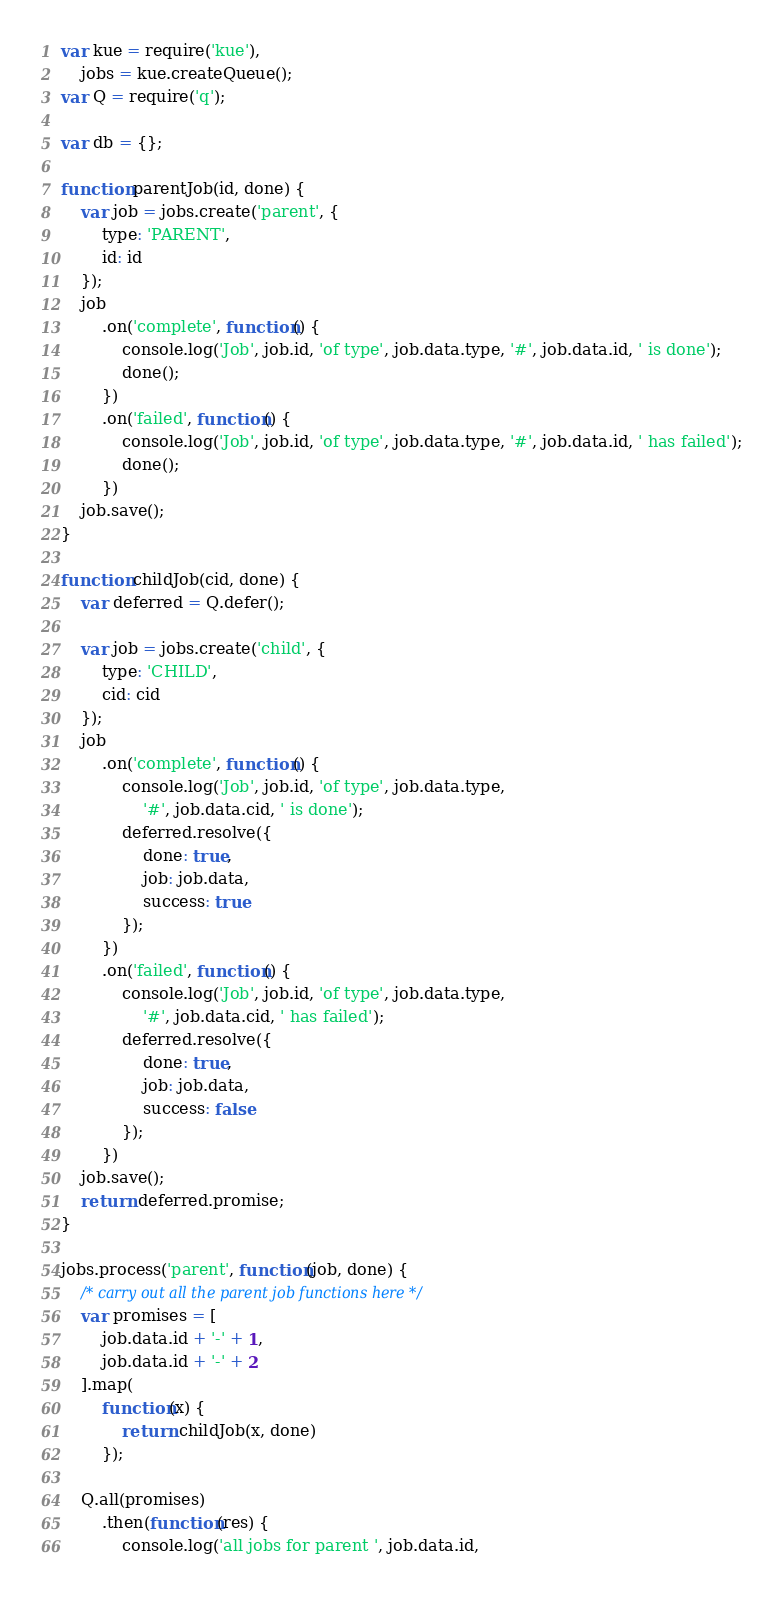Convert code to text. <code><loc_0><loc_0><loc_500><loc_500><_JavaScript_>var kue = require('kue'),
    jobs = kue.createQueue();
var Q = require('q');

var db = {};

function parentJob(id, done) {
    var job = jobs.create('parent', {
        type: 'PARENT',
        id: id
    });
    job
        .on('complete', function() {
            console.log('Job', job.id, 'of type', job.data.type, '#', job.data.id, ' is done');
            done();
        })
        .on('failed', function() {
            console.log('Job', job.id, 'of type', job.data.type, '#', job.data.id, ' has failed');
            done();
        })
    job.save();
}

function childJob(cid, done) {
    var deferred = Q.defer();

    var job = jobs.create('child', {
        type: 'CHILD',
        cid: cid
    });
    job
        .on('complete', function() {
            console.log('Job', job.id, 'of type', job.data.type,
                '#', job.data.cid, ' is done');
            deferred.resolve({
                done: true,
                job: job.data,
                success: true
            });
        })
        .on('failed', function() {
            console.log('Job', job.id, 'of type', job.data.type,
                '#', job.data.cid, ' has failed');
            deferred.resolve({
                done: true,
                job: job.data,
                success: false
            });
        })
    job.save();
    return deferred.promise;
}

jobs.process('parent', function(job, done) {
    /* carry out all the parent job functions here */
    var promises = [
        job.data.id + '-' + 1,
        job.data.id + '-' + 2
    ].map(
        function(x) {
            return childJob(x, done)
        });

    Q.all(promises)
        .then(function(res) {
            console.log('all jobs for parent ', job.data.id,</code> 